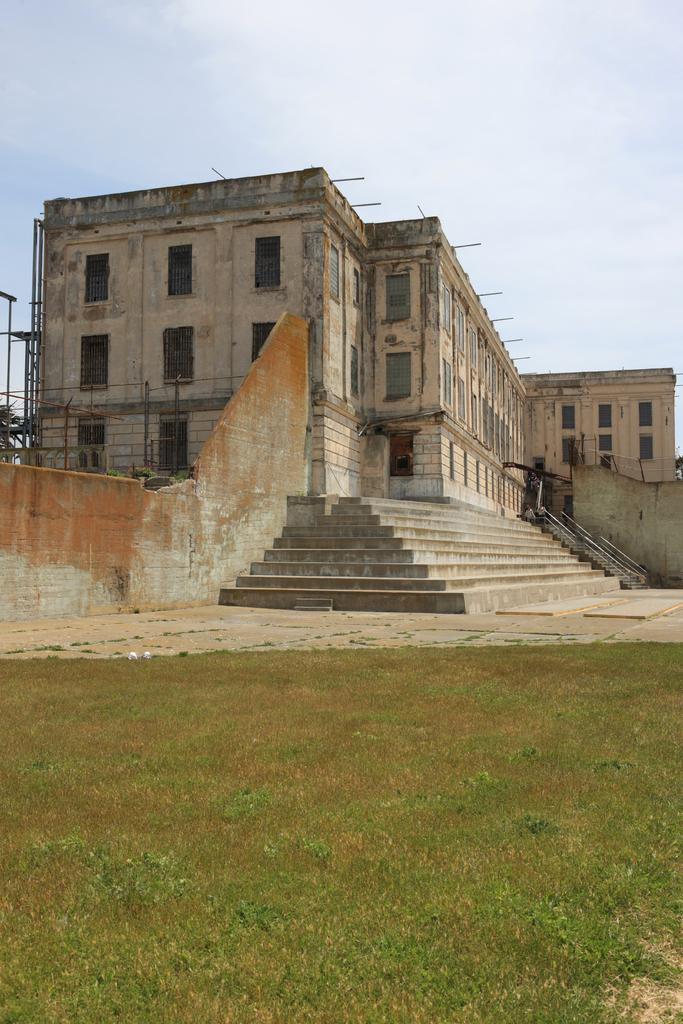What type of vegetation can be seen in the image? There is grass in the image. What architectural feature is present in the image? There are steps in the image. What structures are visible in the image? There are walls and a building in the image. What is visible in the background of the image? The sky is visible in the background of the image. What can be seen in the sky? There are clouds in the sky. What type of food is the yak eating in the image? There is no yak present in the image, so it cannot be determined what, if any, food it might be eating. What government policies are being discussed in the image? There is no discussion of government policies in the image. 